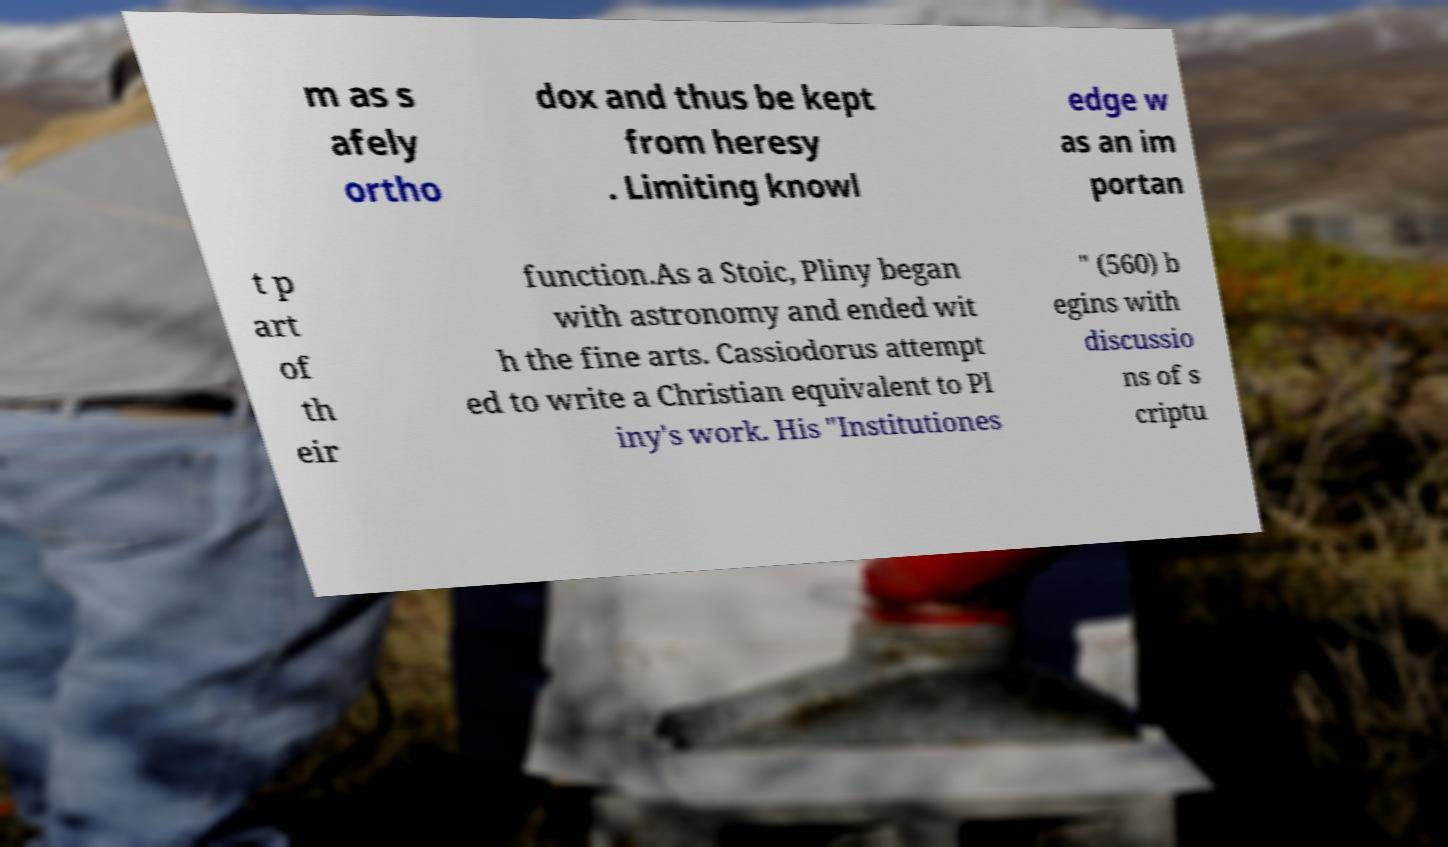Could you assist in decoding the text presented in this image and type it out clearly? m as s afely ortho dox and thus be kept from heresy . Limiting knowl edge w as an im portan t p art of th eir function.As a Stoic, Pliny began with astronomy and ended wit h the fine arts. Cassiodorus attempt ed to write a Christian equivalent to Pl iny's work. His "Institutiones " (560) b egins with discussio ns of s criptu 